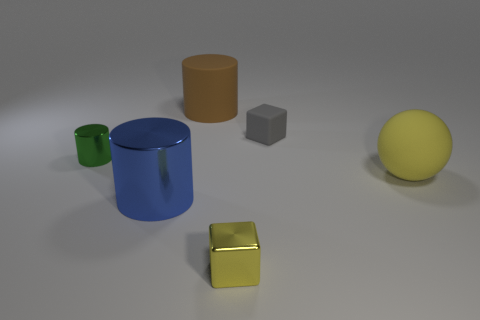Add 3 small green objects. How many objects exist? 9 Subtract all blocks. How many objects are left? 4 Add 5 tiny gray rubber objects. How many tiny gray rubber objects exist? 6 Subtract 0 red spheres. How many objects are left? 6 Subtract all tiny yellow objects. Subtract all small yellow metal things. How many objects are left? 4 Add 4 cylinders. How many cylinders are left? 7 